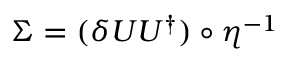<formula> <loc_0><loc_0><loc_500><loc_500>\Sigma = ( \delta { U } U ^ { \dagger } ) \circ \boldsymbol \eta ^ { - 1 }</formula> 